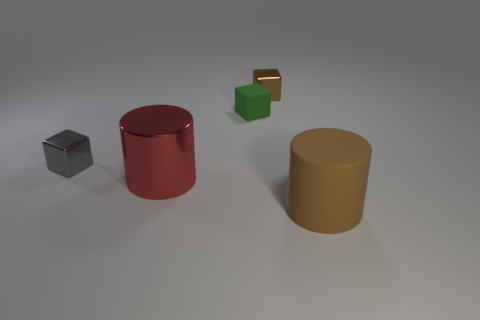Subtract all tiny gray metallic blocks. How many blocks are left? 2 Add 2 gray metallic cubes. How many objects exist? 7 Subtract all blocks. How many objects are left? 2 Add 3 brown cylinders. How many brown cylinders are left? 4 Add 1 big brown blocks. How many big brown blocks exist? 1 Subtract 0 gray balls. How many objects are left? 5 Subtract all blue cubes. Subtract all green spheres. How many cubes are left? 3 Subtract all green cubes. Subtract all cylinders. How many objects are left? 2 